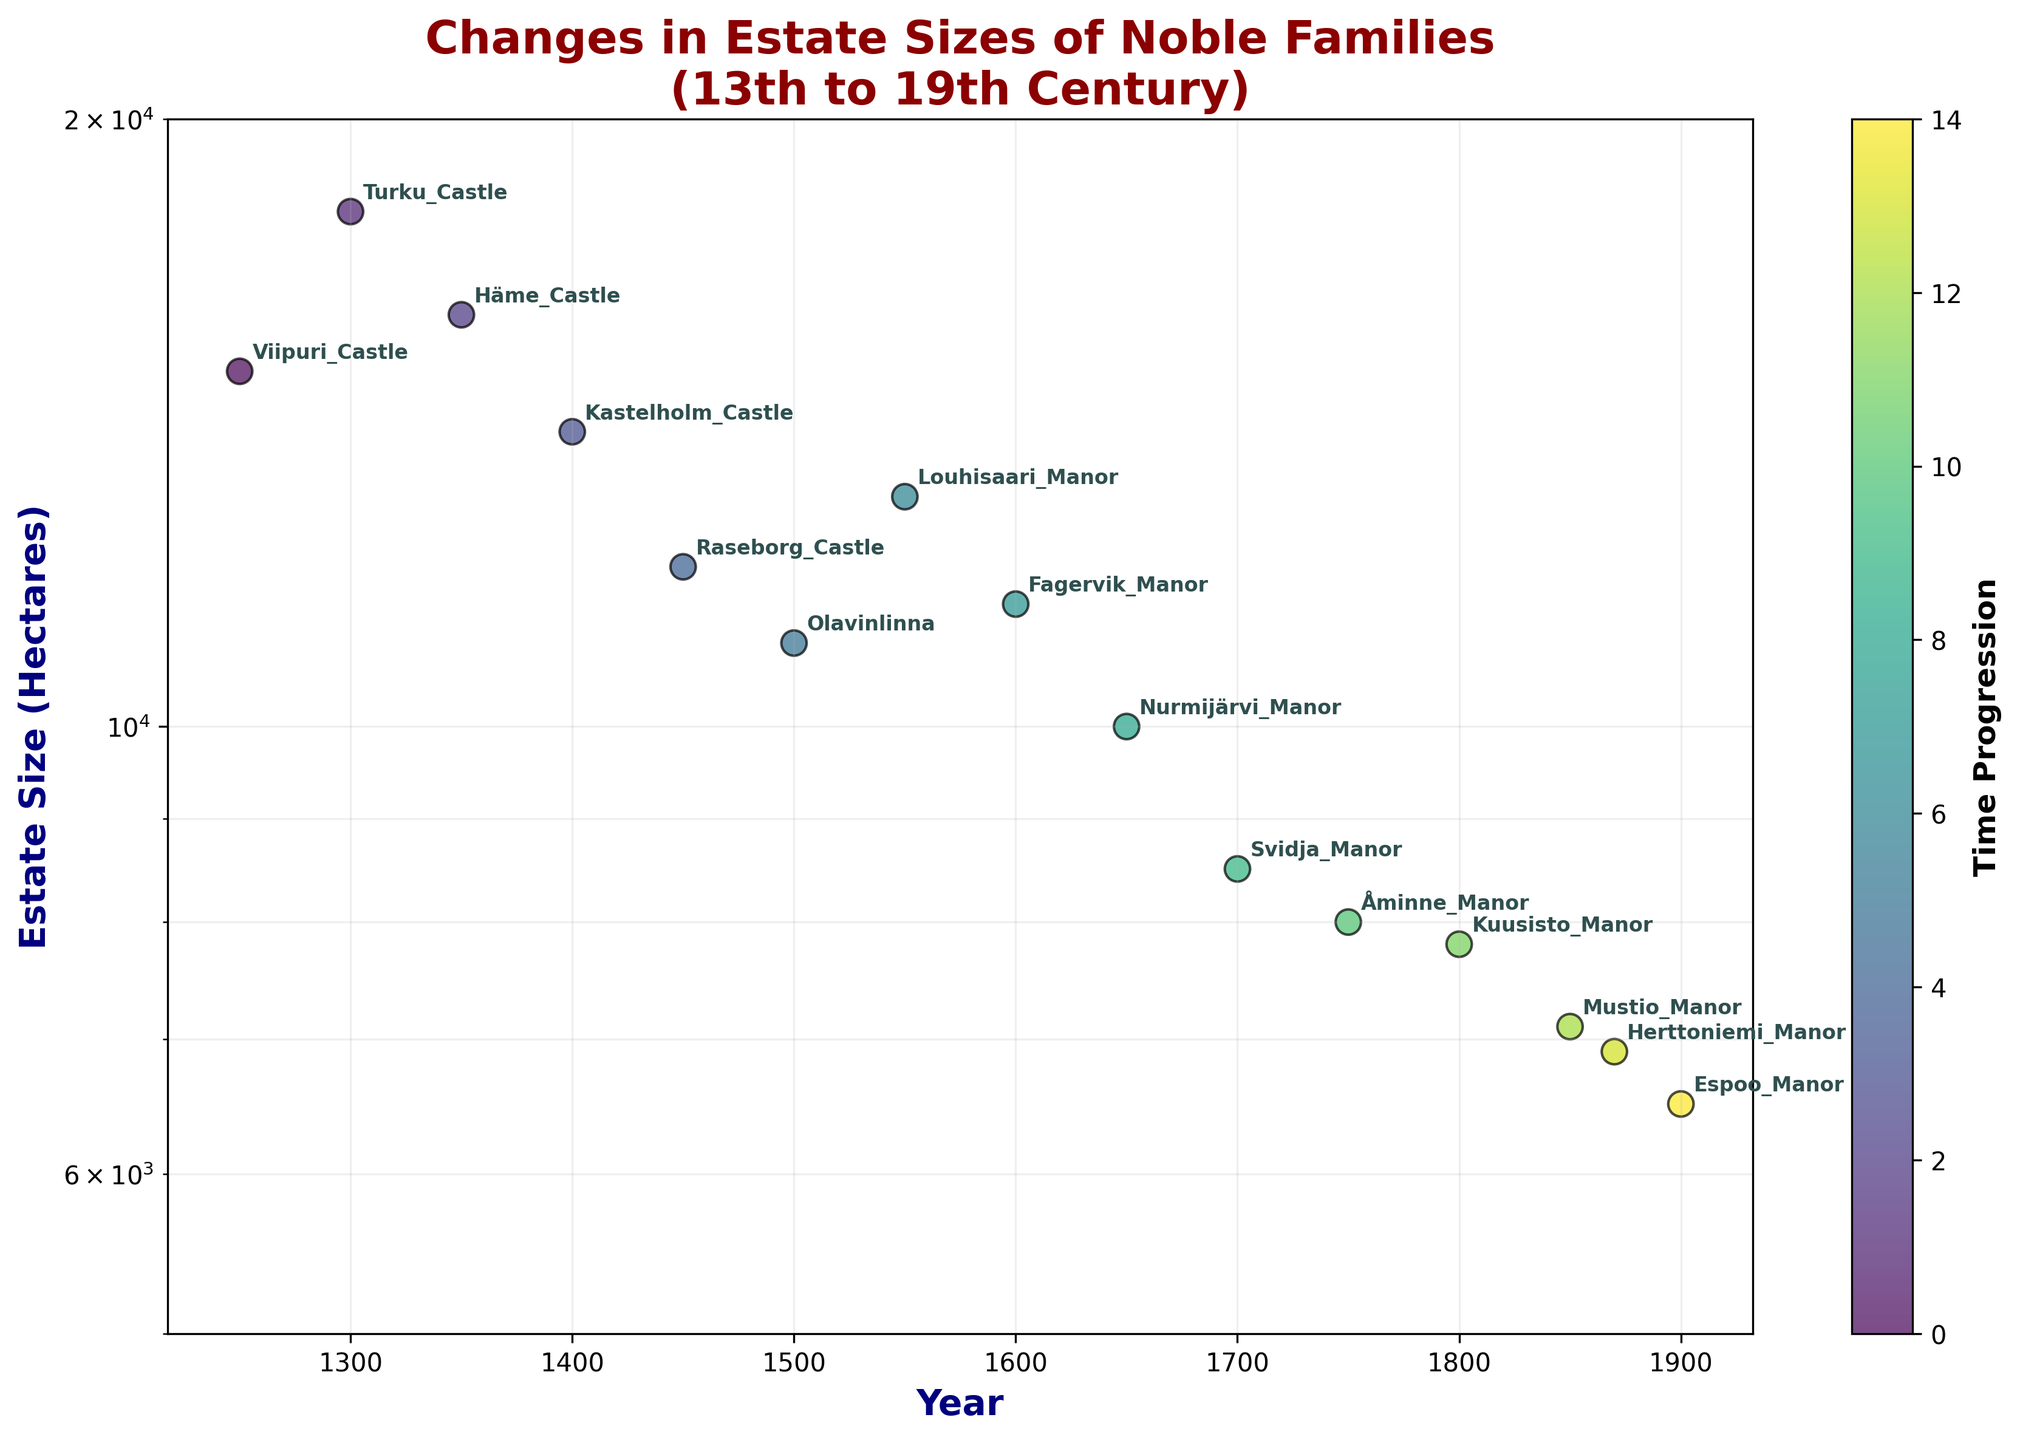How many estates are displayed in the figure? Count the number of unique data points (estate names) displayed in the scatter plot. Each dot represents one estate, and there are 15 dots in total.
Answer: 15 What is the title of the figure? The title is usually displayed at the top of a plot. In this case, it reads "Changes in Estate Sizes of Noble Families\n(13th to 19th Century)".
Answer: Changes in Estate Sizes of Noble Families (13th to 19th Century) Which estate had the largest size in the 15th century? Find the data points corresponding to the 15th century (1400-1499) and compare their sizes. There is only one point for 1450, which is Raseborg Castle with 12,000 hectares.
Answer: Raseborg Castle Between which two consecutive time points did the estate size of Louhisaari Manor change? Identify the time points when Louhisaari Manor appears on the plot. Louhisaari Manor is listed in the year 1550. The consecutive point before is 1500, and after is 1600.
Answer: 1500 and 1600 Which estate shows the smallest size in the plot? Compare the sizes listed next to the plotted points or in the data. The smallest size is for Espoo Manor at 6500 hectares.
Answer: Espoo Manor How does the overall trend of estate sizes change over time? Observe the general direction of the points as time progresses from left to right. The sizes generally decrease over time, indicating a trend of decreasing estate sizes.
Answer: Decreasing trend What is the estate size for Turku Castle in the year 1300? Locate Turku Castle in the plot and read the size annotated next to it. The size is 18,000 hectares.
Answer: 18,000 hectares Compare the size of Häme Castle and Kastelholm Castle. Which one is larger? Look for Häme Castle and Kastelholm Castle in the plot and compare their sizes. Häme Castle has 16,000 hectares, while Kastelholm Castle has 14,000 hectares.
Answer: Häme Castle What is the difference in size between the largest and smallest estates? Identify the largest and smallest estate sizes. The largest is Turku Castle with 18,000 hectares, and the smallest is Espoo Manor with 6,500 hectares. The difference is calculated as 18,000 - 6,500 = 11,500.
Answer: 11,500 hectares What kind of scale is used for the y-axis? Examine the label or any notation on the y-axis. The y-axis uses a logarithmic scale, indicated by the term 'log' mentioned in the description.
Answer: Logarithmic scale 